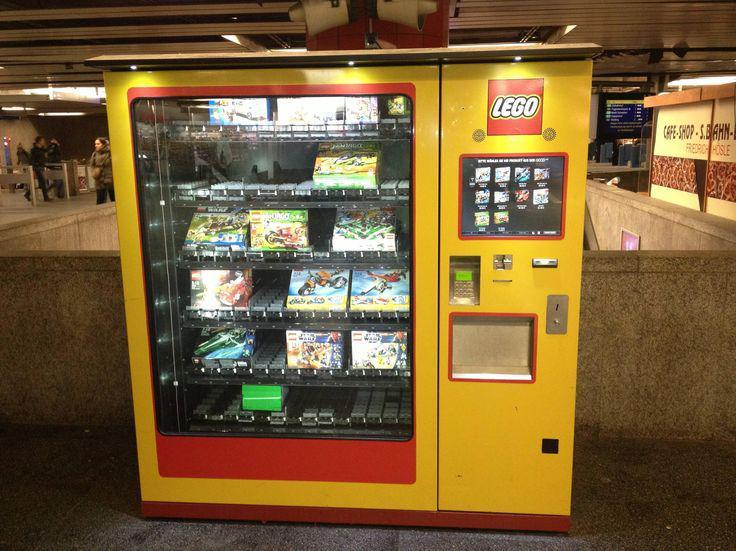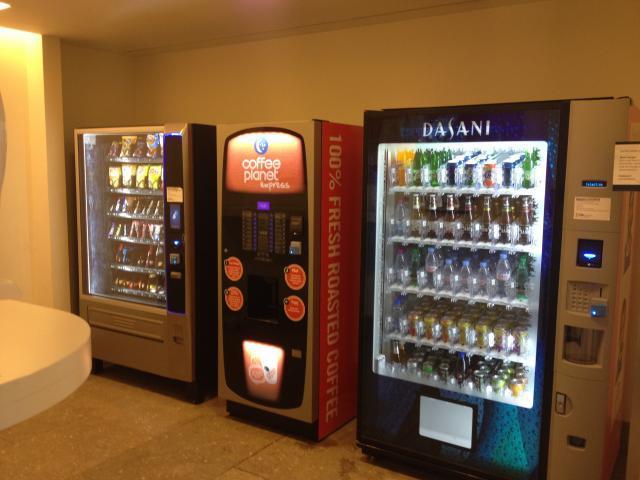The first image is the image on the left, the second image is the image on the right. Examine the images to the left and right. Is the description "In at least one of the images, at least three vending machines are shown in three unique colors including blue and red." accurate? Answer yes or no. Yes. The first image is the image on the left, the second image is the image on the right. Assess this claim about the two images: "One image shows a horizontal row of exactly three vending machines, with none more than about a foot apart.". Correct or not? Answer yes or no. Yes. 